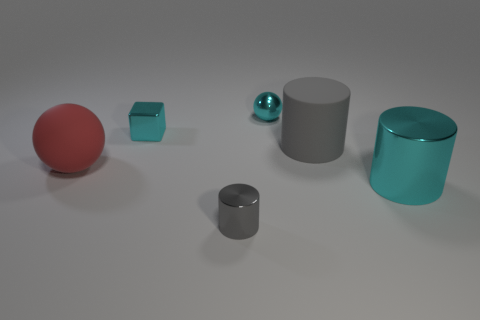Add 1 cubes. How many objects exist? 7 Subtract all spheres. How many objects are left? 4 Subtract 0 blue blocks. How many objects are left? 6 Subtract all big gray matte objects. Subtract all gray rubber blocks. How many objects are left? 5 Add 6 blocks. How many blocks are left? 7 Add 4 tiny shiny cubes. How many tiny shiny cubes exist? 5 